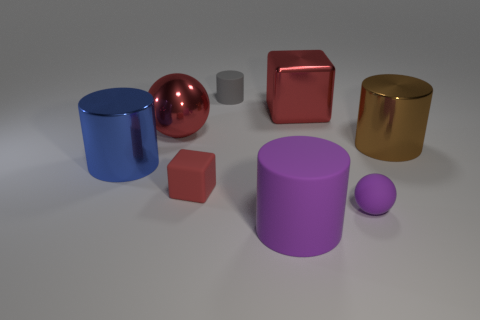How do the varying textures of the objects affect the perception of the image? The textures play a significant role in the perception of the image. The shiny textures of the red sphere and golden cylinder create highlights and reflect the environment, adding depth and realism. The matte surfaces of the cylinders and cubes absorb light differently, giving the image a contrast in finishes that adds visual interest and makes each shape distinctively recognizable. 